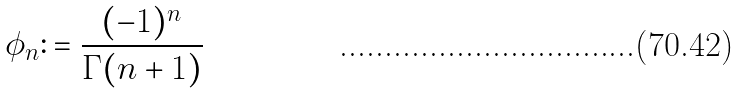Convert formula to latex. <formula><loc_0><loc_0><loc_500><loc_500>\phi _ { n } \colon = \frac { ( - 1 ) ^ { n } } { \Gamma ( n + 1 ) }</formula> 